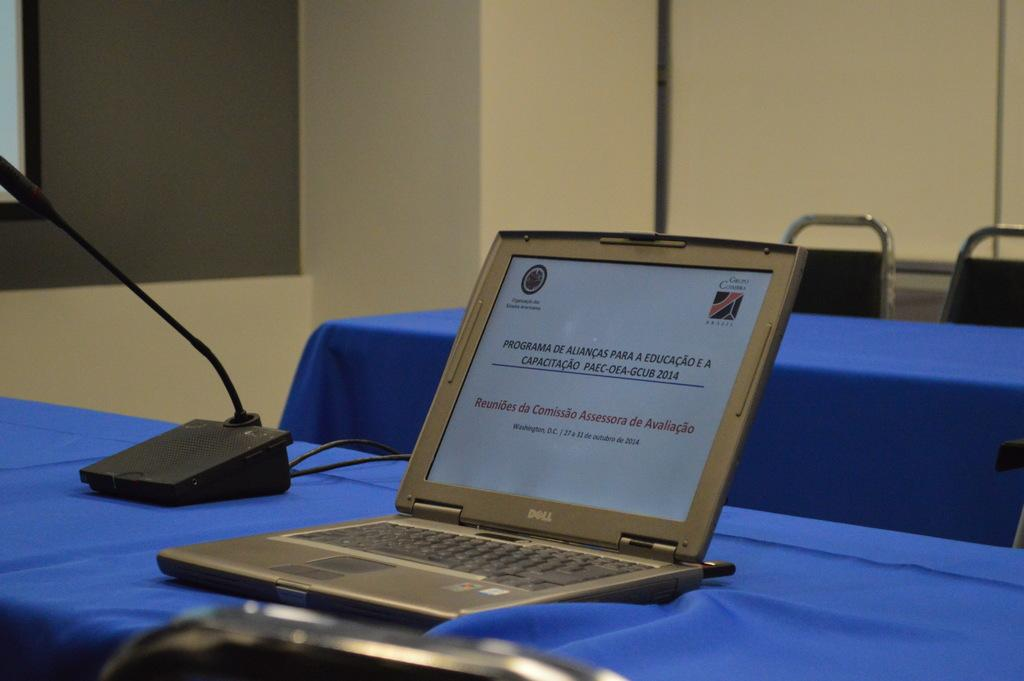Provide a one-sentence caption for the provided image. An open Dell laptop and a black microphone on a stand on top of a table covered in blue. 